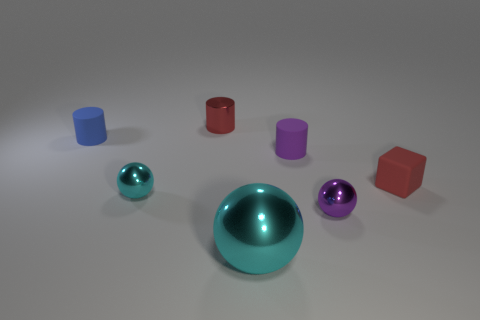What number of things are either cylinders that are to the left of the small purple matte object or small purple cylinders?
Keep it short and to the point. 3. How many objects are purple shiny balls or tiny matte things that are to the left of the red rubber object?
Your response must be concise. 3. How many purple rubber cylinders have the same size as the red metal object?
Give a very brief answer. 1. Is the number of big balls behind the large object less than the number of tiny purple shiny things in front of the purple metal object?
Provide a succinct answer. No. How many matte things are either tiny cylinders or red objects?
Offer a very short reply. 3. What shape is the purple rubber thing?
Your answer should be compact. Cylinder. There is a cyan ball that is the same size as the purple matte object; what is its material?
Your answer should be very brief. Metal. How many big objects are either cyan metallic objects or purple shiny things?
Make the answer very short. 1. Are any tiny gray rubber objects visible?
Your response must be concise. No. What size is the blue cylinder that is made of the same material as the small block?
Provide a succinct answer. Small. 